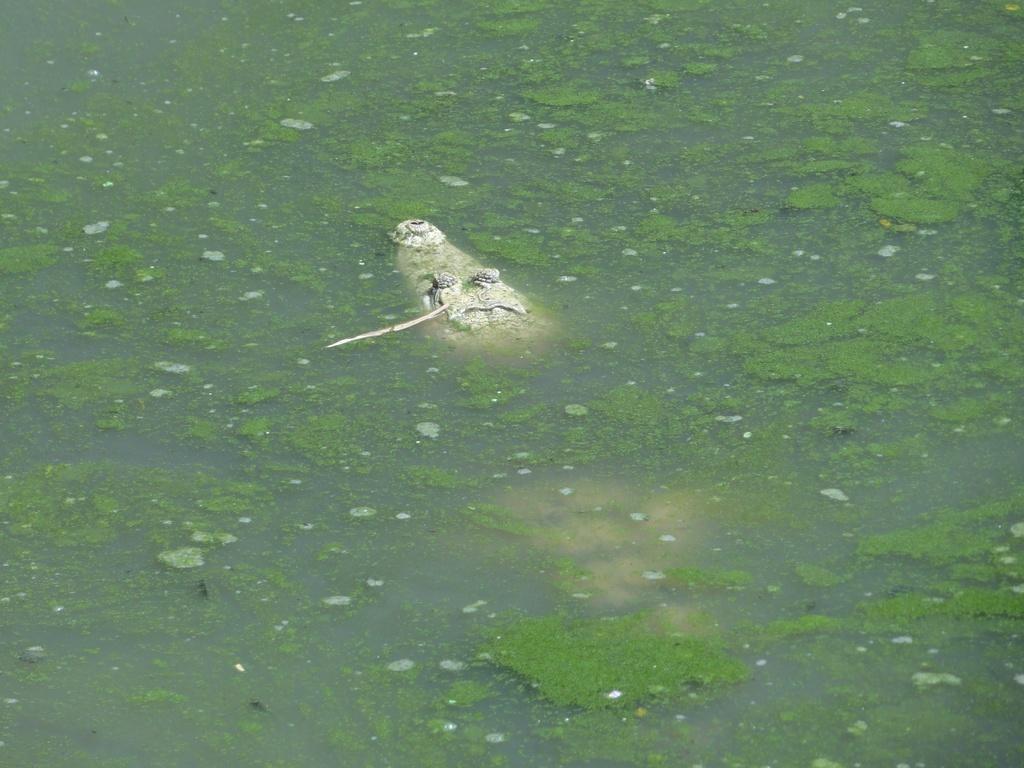Describe this image in one or two sentences. In this image I can see a crocodile in the water. 